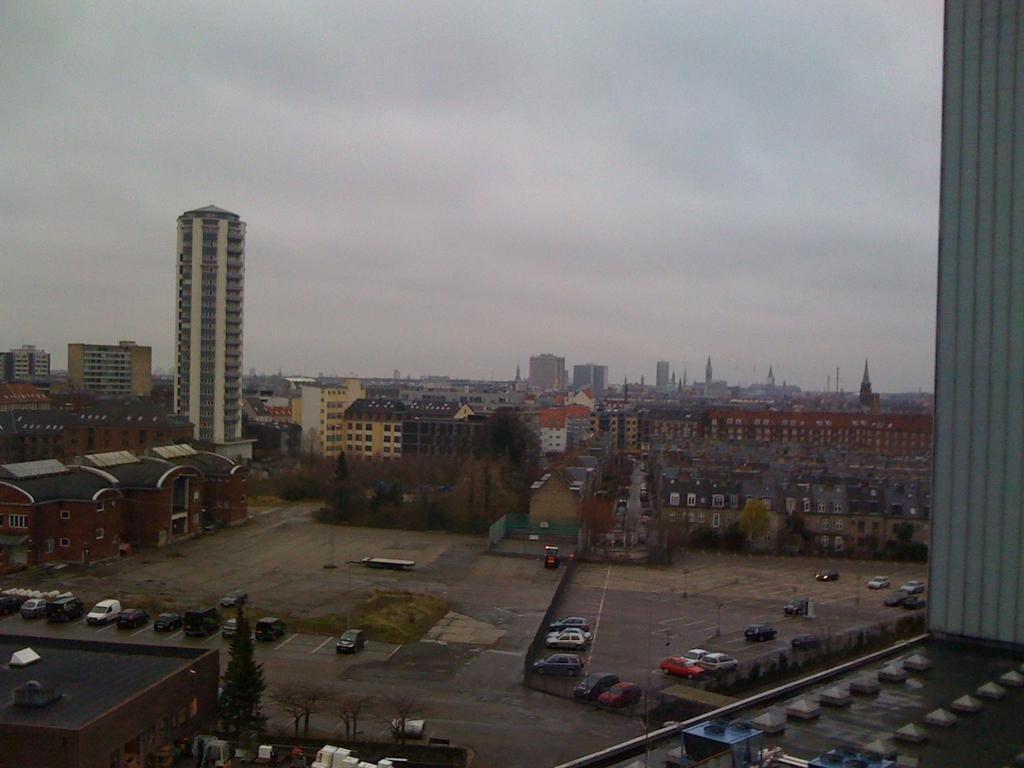Please provide a concise description of this image. This is a picture of a city. In the foreground of the picture there are buildings, cars and trees. In the center of the picture there are buildings, trees and roads. Sky is cloudy. 